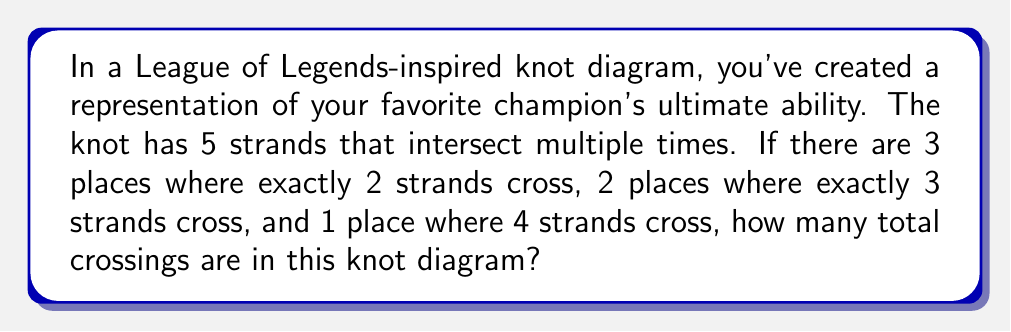Could you help me with this problem? Let's approach this step-by-step:

1) First, let's consider the places where 2 strands cross:
   - There are 3 such places
   - Each of these contributes 1 crossing
   - Total crossings from 2-strand intersections: $3 \times 1 = 3$

2) Now, let's look at the places where 3 strands cross:
   - There are 2 such places
   - In each of these, we need to count the number of crossings
   - For 3 strands, the number of crossings is $\binom{3}{2} = 3$
   - Total crossings from 3-strand intersections: $2 \times 3 = 6$

3) Finally, let's consider the place where 4 strands cross:
   - There is 1 such place
   - For 4 strands, the number of crossings is $\binom{4}{2} = 6$
   - Total crossings from the 4-strand intersection: $1 \times 6 = 6$

4) To get the total number of crossings, we sum all these:
   $3 + 6 + 6 = 15$

Therefore, there are 15 total crossings in this knot diagram.
Answer: 15 